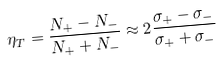<formula> <loc_0><loc_0><loc_500><loc_500>\eta _ { T } = \frac { N _ { + } - N _ { - } } { N _ { + } + N _ { - } } \approx 2 \frac { \sigma _ { + } - \sigma _ { - } } { \sigma _ { + } + \sigma _ { - } }</formula> 